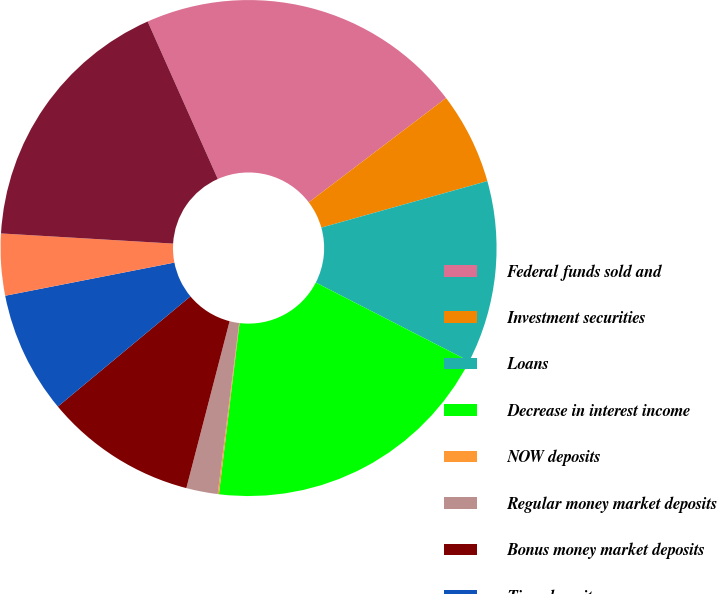Convert chart to OTSL. <chart><loc_0><loc_0><loc_500><loc_500><pie_chart><fcel>Federal funds sold and<fcel>Investment securities<fcel>Loans<fcel>Decrease in interest income<fcel>NOW deposits<fcel>Regular money market deposits<fcel>Bonus money market deposits<fcel>Time deposits<fcel>Decrease in interest expense<fcel>Decrease in net interest<nl><fcel>21.34%<fcel>5.99%<fcel>11.9%<fcel>19.37%<fcel>0.08%<fcel>2.05%<fcel>9.93%<fcel>7.96%<fcel>4.02%<fcel>17.4%<nl></chart> 